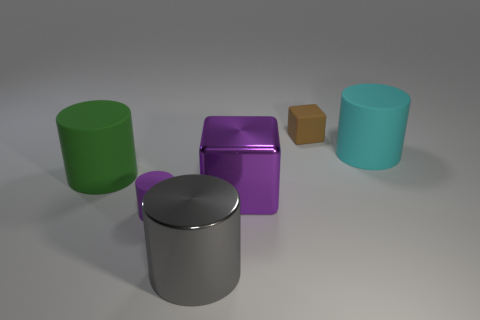Is the number of purple metal things that are to the left of the purple cylinder greater than the number of large cylinders that are in front of the tiny matte cube?
Your response must be concise. No. How many cylinders are the same size as the matte cube?
Provide a short and direct response. 1. Is the number of green things that are in front of the large purple shiny object less than the number of tiny rubber cubes that are on the right side of the big metal cylinder?
Provide a succinct answer. Yes. Are there any gray shiny things that have the same shape as the brown matte object?
Your answer should be very brief. No. Do the gray metallic thing and the large purple metal object have the same shape?
Keep it short and to the point. No. How many large things are either shiny cubes or gray metallic cylinders?
Provide a short and direct response. 2. Is the number of blocks greater than the number of cylinders?
Your response must be concise. No. There is a green thing that is the same material as the tiny purple cylinder; what size is it?
Offer a very short reply. Large. Does the block that is behind the big cyan rubber cylinder have the same size as the thing in front of the purple matte thing?
Your answer should be compact. No. How many things are big matte cylinders left of the purple cylinder or big gray rubber balls?
Keep it short and to the point. 1. 